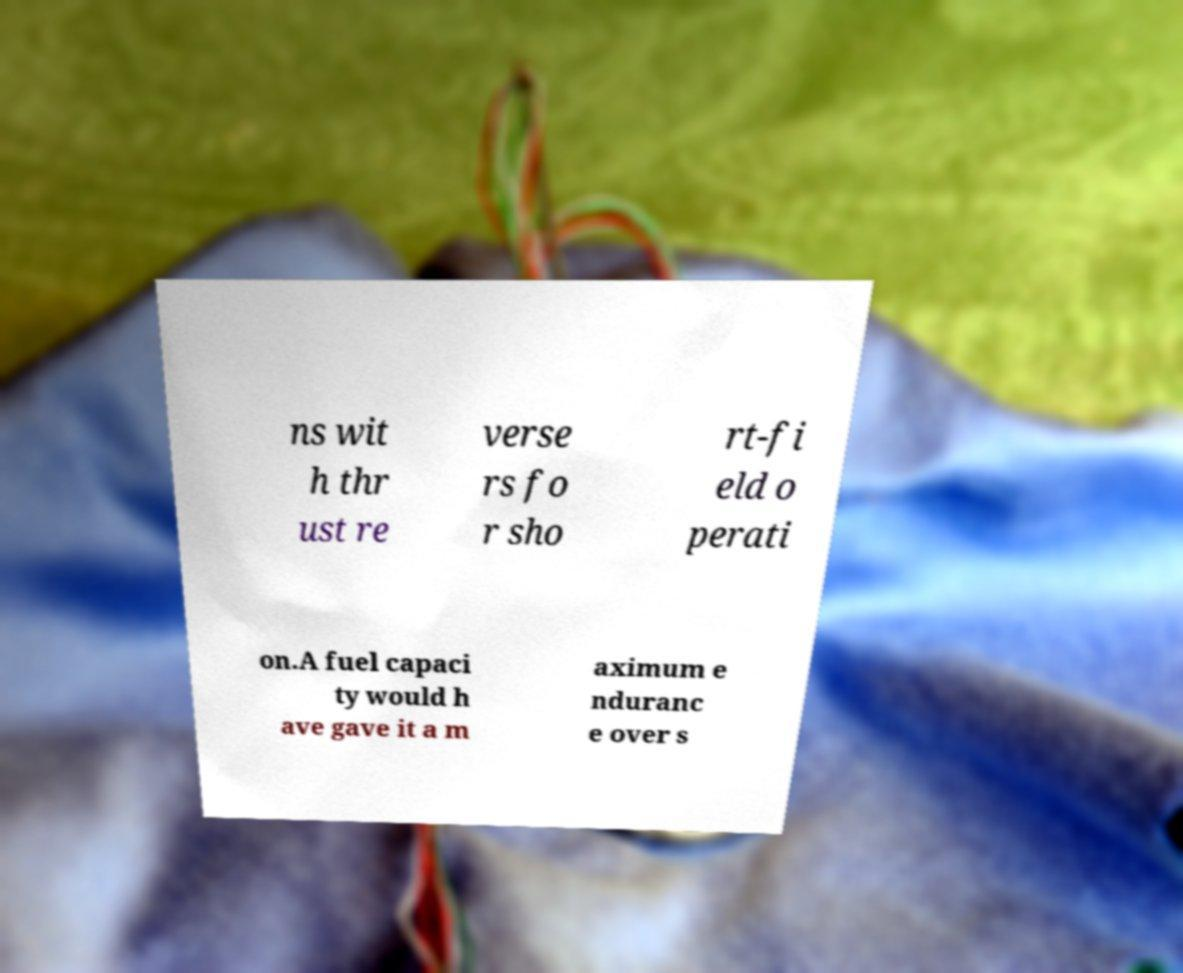Can you read and provide the text displayed in the image?This photo seems to have some interesting text. Can you extract and type it out for me? ns wit h thr ust re verse rs fo r sho rt-fi eld o perati on.A fuel capaci ty would h ave gave it a m aximum e nduranc e over s 